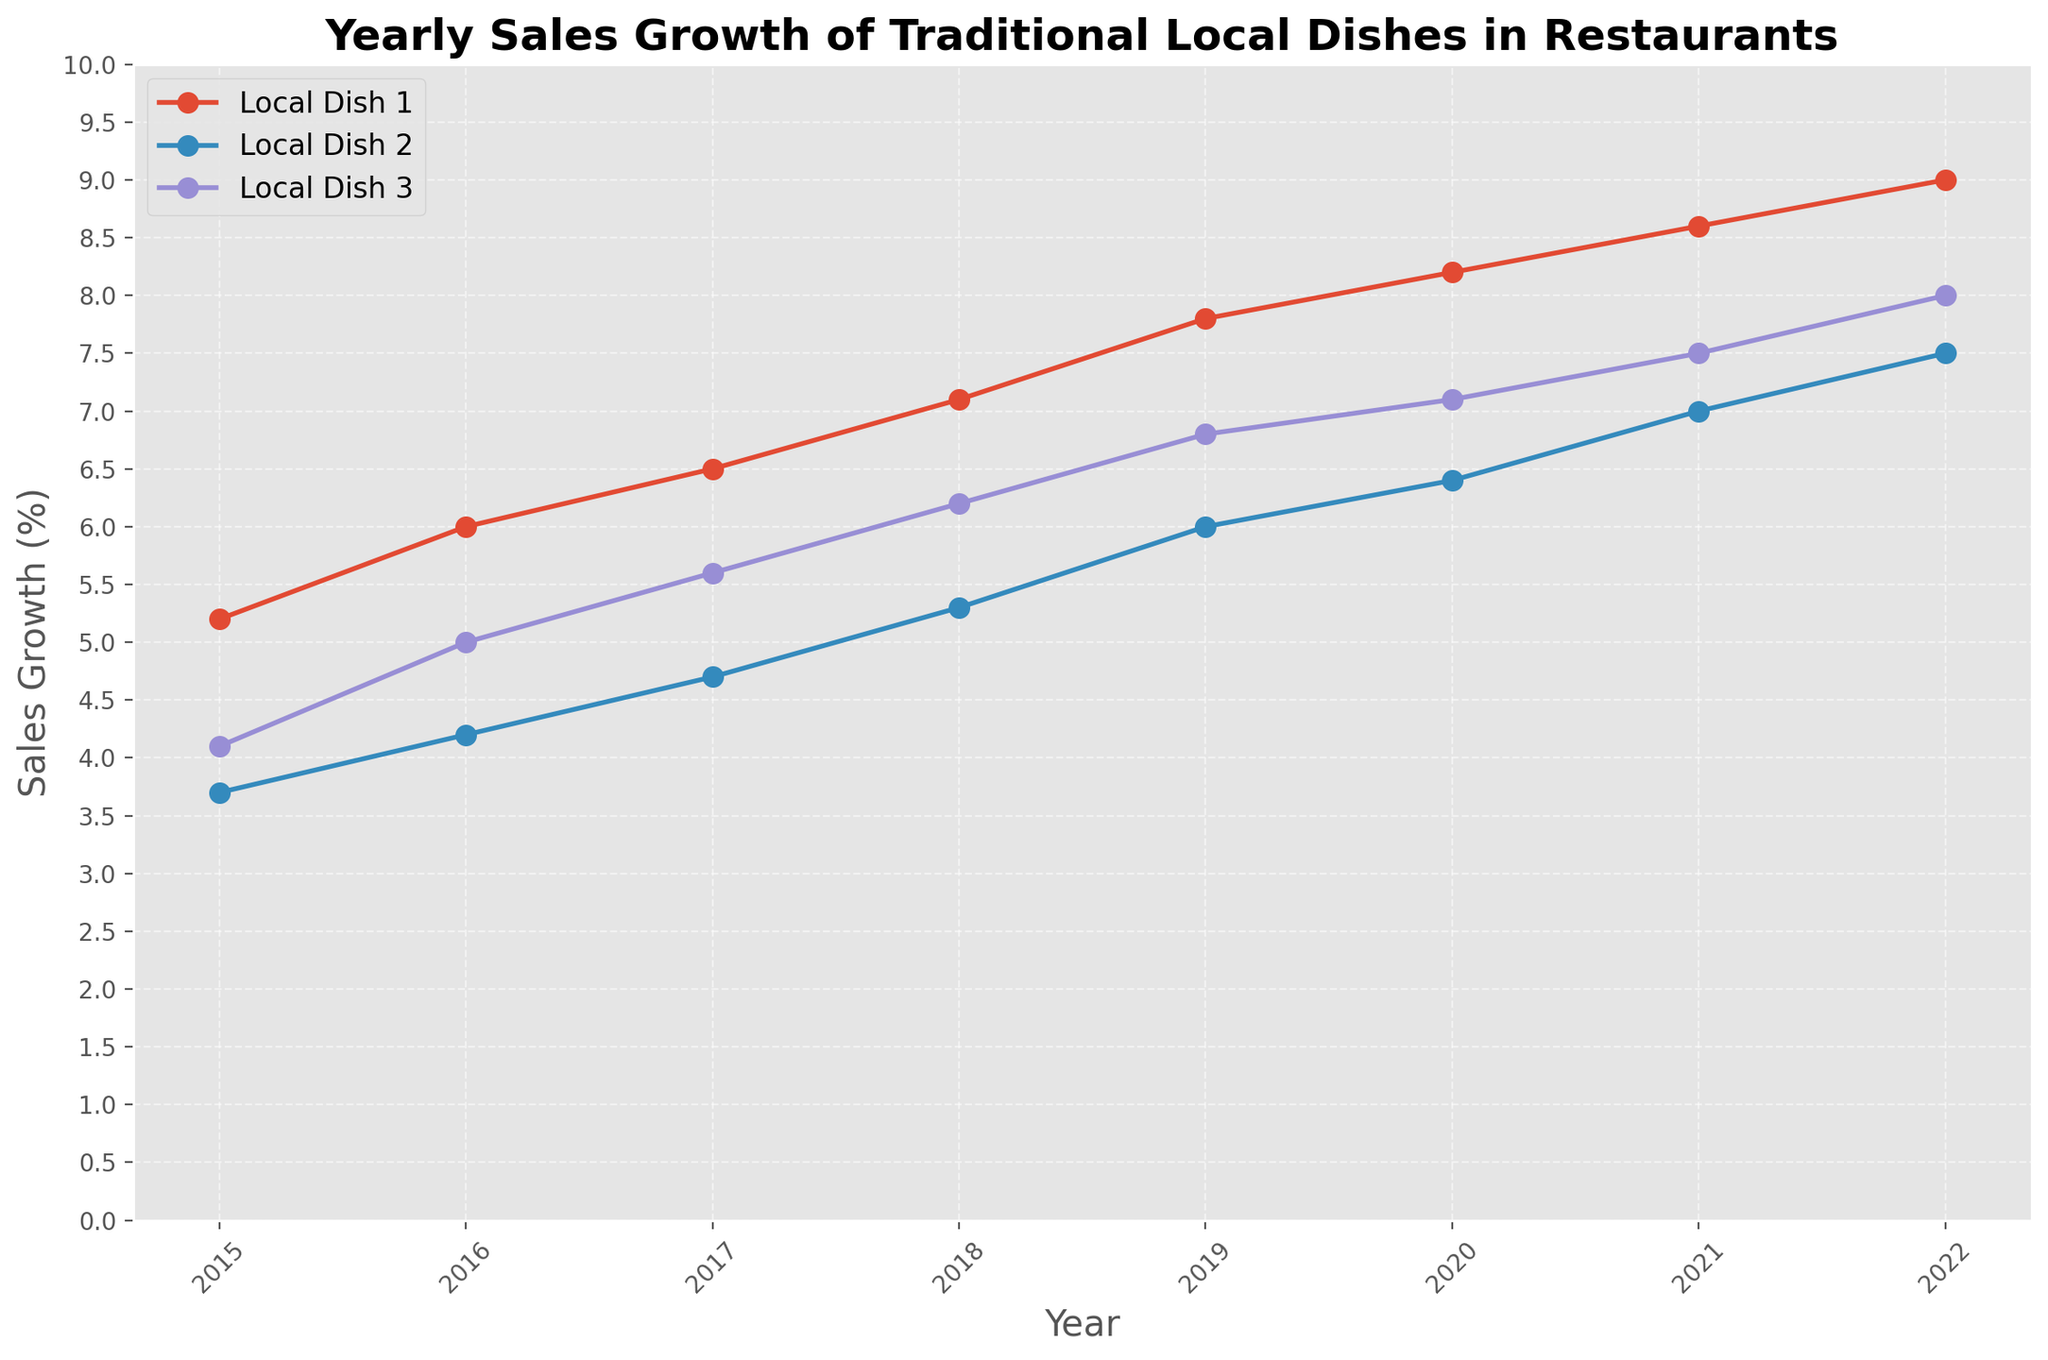What is the overall trend of sales growth for Local Dish 1 from 2015 to 2022? To determine the trend, observe the line for Local Dish 1 over the years 2015 to 2022. The sales growth for Local Dish 1 continuously increases from 5.2% in 2015 to 9.0% in 2022. This indicates a steady upward trend.
Answer: Upward trend Which year shows the highest sales growth for Local Dish 2? Look at the line corresponding to Local Dish 2 and identify the peak point. The highest sales growth for Local Dish 2 is in 2022, with a growth percentage of 7.5%.
Answer: 2022 How does the sales growth of Local Dish 3 in 2019 compare to that of Local Dish 1 in 2019? Identify the growth percentages for both dishes in 2019 from the lines. Local Dish 3 has a sales growth of 6.8% in 2019, and Local Dish 1 has 7.8%, showing that Local Dish 1's sales growth is higher.
Answer: Local Dish 1 has higher growth Between 2020 and 2021, which traditional dish had the smallest increase in sales growth? Calculate the difference in sales growth percentages between 2020 and 2021 for each dish. Local Dish 1 increased by 0.4% (8.2% to 8.6%), Local Dish 2 increased by 0.6% (6.4% to 7.0%), and Local Dish 3 increased by 0.4% (7.1% to 7.5%). Local Dish 1 and Local Dish 3 both had the smallest increase of 0.4%.
Answer: Local Dish 1 and Local Dish 3 What is the average sales growth percentage for Local Dish 2 from 2015 to 2022? Sum up all the sales growth values for Local Dish 2 from 2015 to 2022 and divide by the number of years (8). (3.7 + 4.2 + 4.7 + 5.3 + 6.0 + 6.4 + 7.0 + 7.5) / 8 = 5.35%
Answer: 5.35% In which year did Local Dish 3 see exactly a 7.1% sales growth? Observe the line for Local Dish 3 and find the year corresponding to a 7.1% sales growth. It is in the year 2020.
Answer: 2020 Does Local Dish 1 show a consistent increase in sales growth every year? Check the values for Local Dish 1 for each year from 2015 to 2022. Sales growth increases every single year: 5.2 (2015), 6.0 (2016), 6.5 (2017), 7.1 (2018), 7.8 (2019), 8.2 (2020), 8.6 (2021), 9.0 (2022).
Answer: Yes Between Local Dish 2 and Local Dish 3, which one shows a higher variability in sales growth from 2015 to 2022? Calculate the range of sales growth for both dishes (maximum - minimum). Local Dish 2: 7.5 - 3.7 = 3.8, Local Dish 3: 8.0 - 4.1 = 3.9. Local Dish 3 shows a higher variability.
Answer: Local Dish 3 What is the difference in sales growth between Local Dish 1 and Local Dish 2 in 2018? Identify the sales growth values for Local Dish 1 and Local Dish 2 in 2018. Local Dish 1 has 7.1%, and Local Dish 2 has 5.3%. The difference is 7.1% - 5.3% = 1.8%.
Answer: 1.8% 